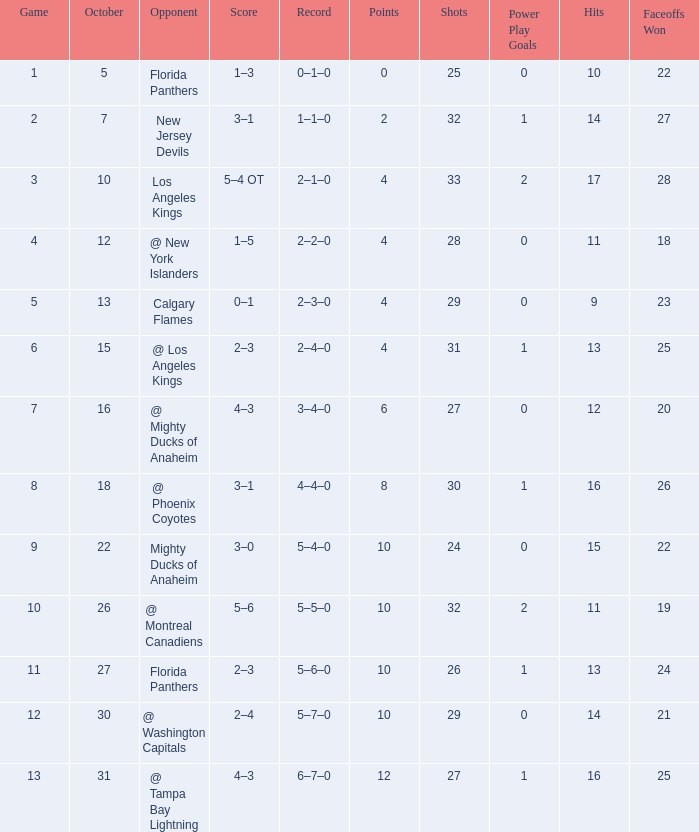What team has a score of 11 5–6–0. 